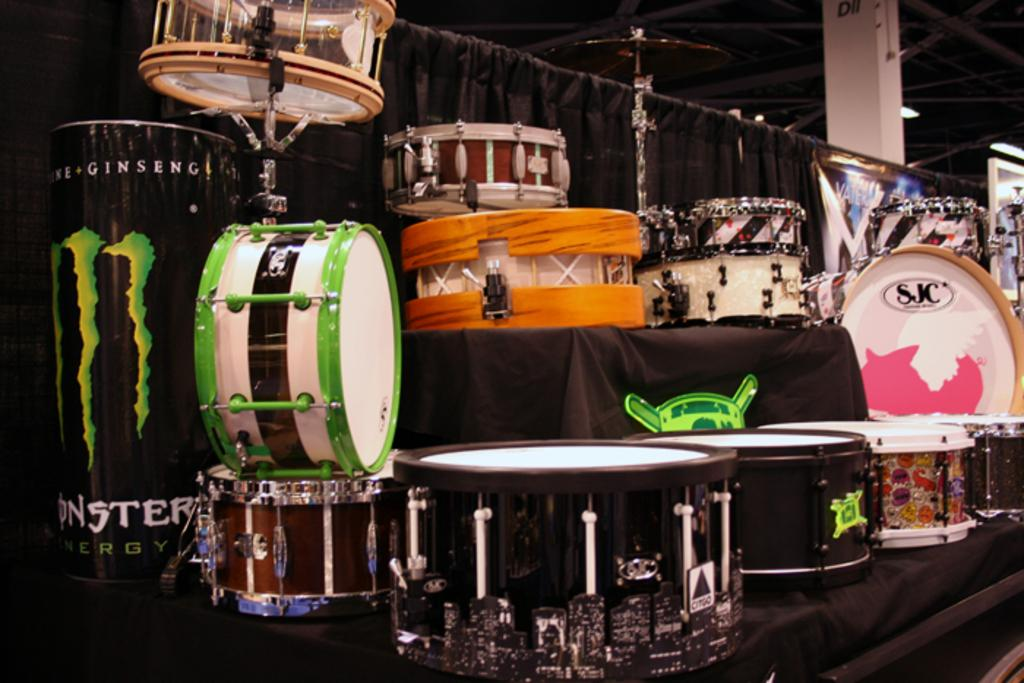What is the main subject in the center of the image? There are musical instruments in the center of the image. What can be seen in the background of the image? There is a black color curtain and a pillar in the background of the image. What is the color of the pillar? The pillar is white in color. Can you see a friend playing the musical instruments with the person in the image? There is no mention of a friend or a person playing the musical instruments in the image. The image only shows the musical instruments themselves. 